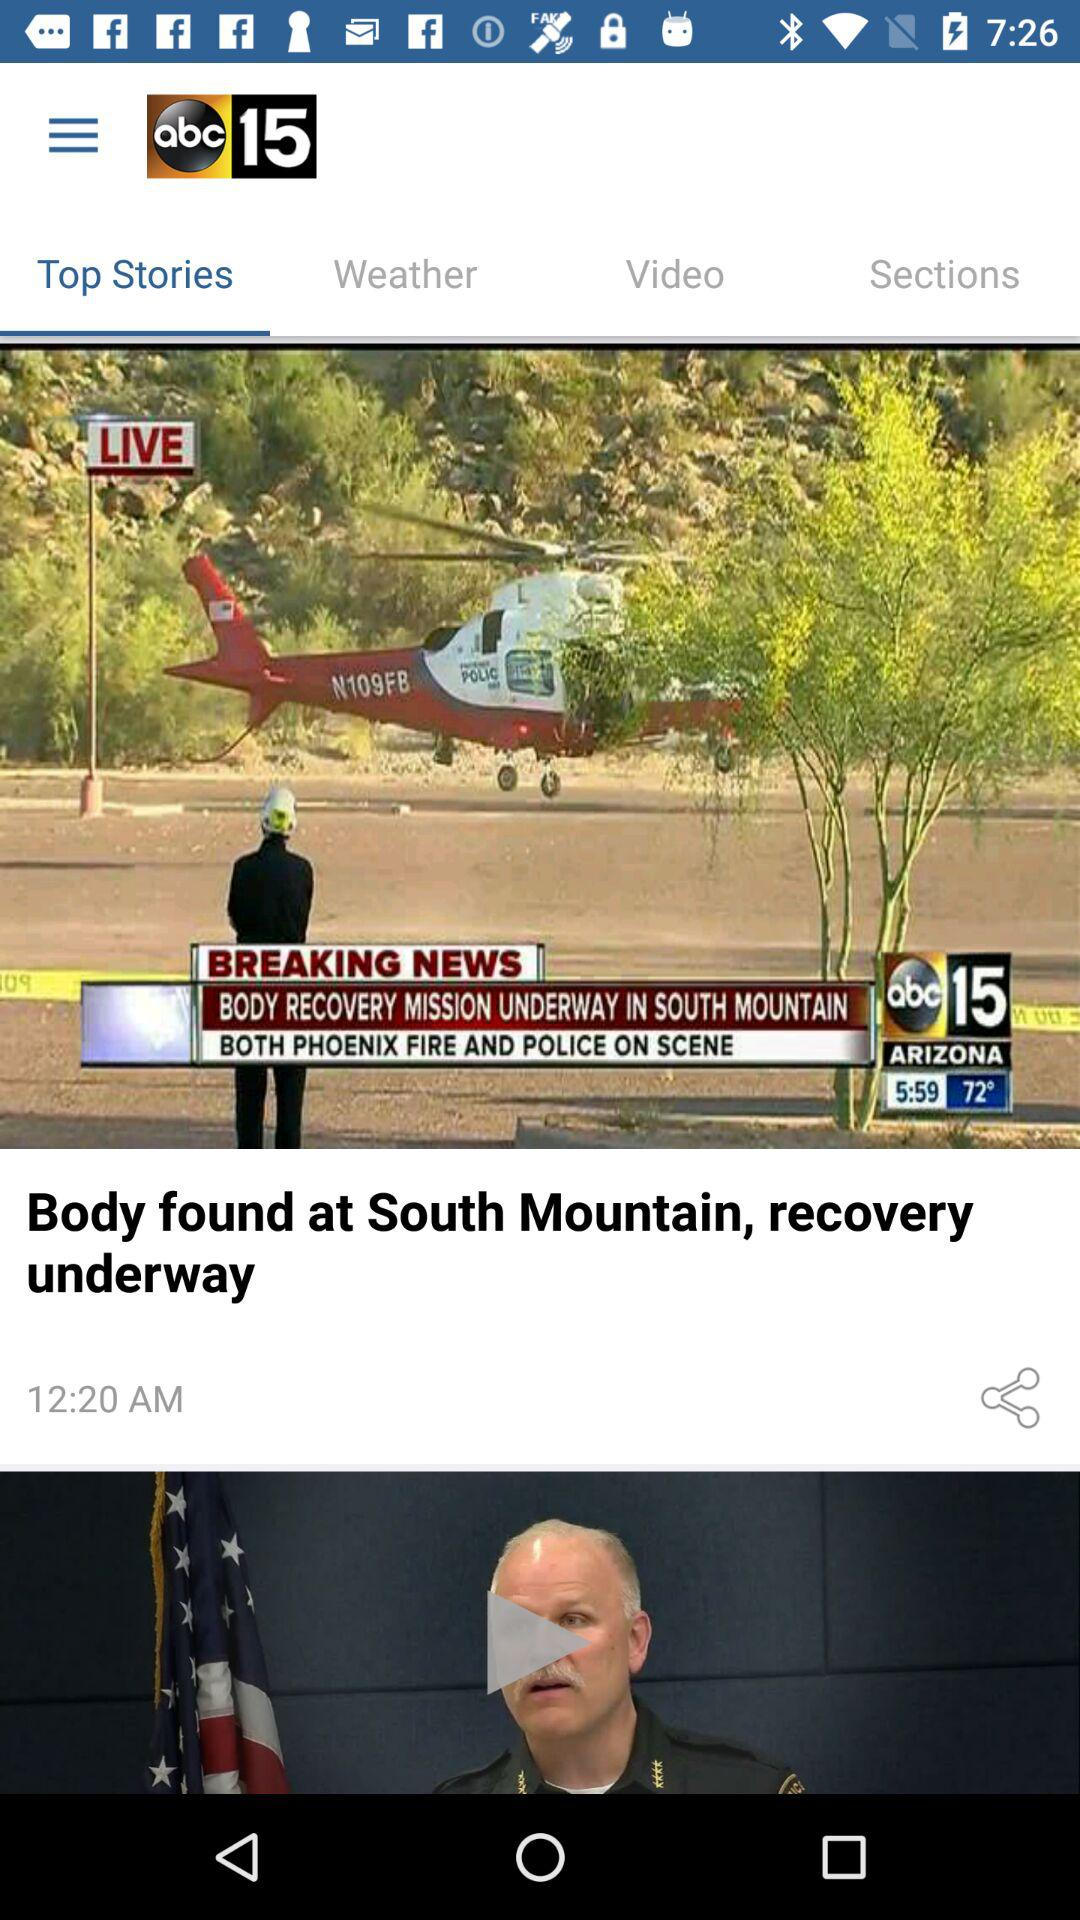What is the news channel name? The news channel name is "abc15 ARIZONA". 